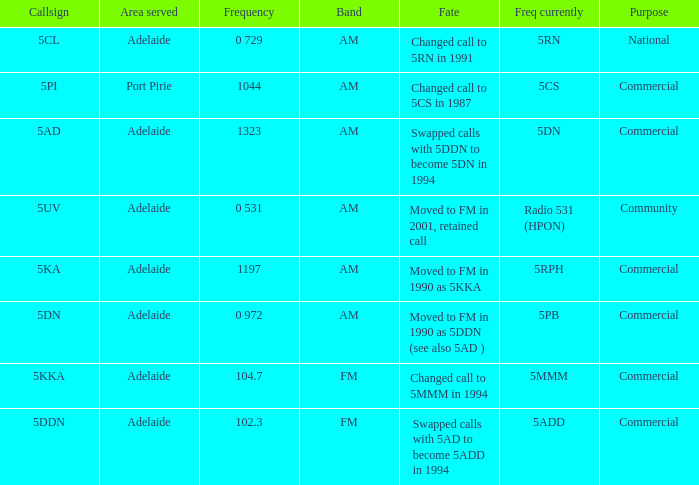What is the current freq for Frequency of 104.7? 5MMM. 